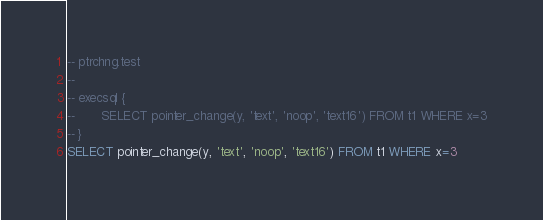<code> <loc_0><loc_0><loc_500><loc_500><_SQL_>-- ptrchng.test
-- 
-- execsql {
--       SELECT pointer_change(y, 'text', 'noop', 'text16') FROM t1 WHERE x=3
-- }
SELECT pointer_change(y, 'text', 'noop', 'text16') FROM t1 WHERE x=3</code> 